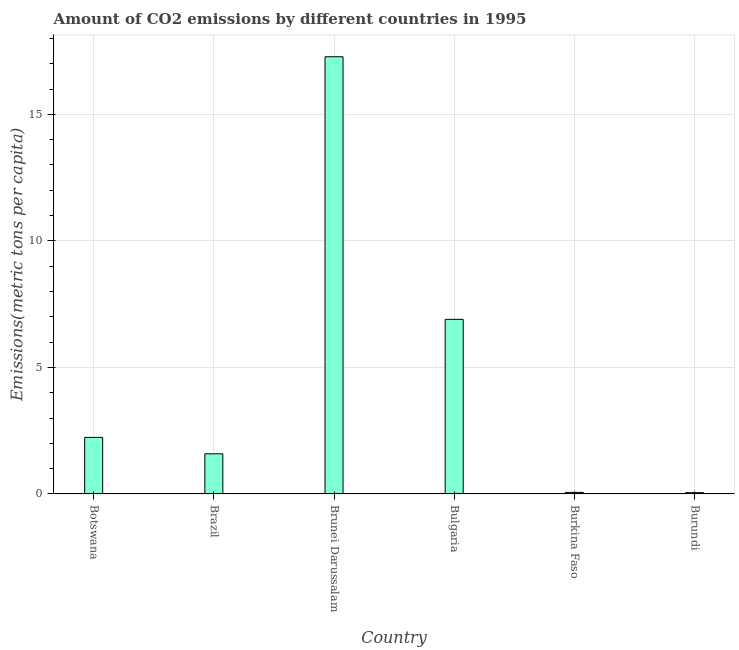Does the graph contain any zero values?
Provide a short and direct response. No. What is the title of the graph?
Offer a terse response. Amount of CO2 emissions by different countries in 1995. What is the label or title of the Y-axis?
Your answer should be compact. Emissions(metric tons per capita). What is the amount of co2 emissions in Brunei Darussalam?
Provide a short and direct response. 17.28. Across all countries, what is the maximum amount of co2 emissions?
Your response must be concise. 17.28. Across all countries, what is the minimum amount of co2 emissions?
Offer a very short reply. 0.05. In which country was the amount of co2 emissions maximum?
Give a very brief answer. Brunei Darussalam. In which country was the amount of co2 emissions minimum?
Your response must be concise. Burundi. What is the sum of the amount of co2 emissions?
Give a very brief answer. 28.11. What is the difference between the amount of co2 emissions in Brunei Darussalam and Bulgaria?
Make the answer very short. 10.38. What is the average amount of co2 emissions per country?
Offer a very short reply. 4.69. What is the median amount of co2 emissions?
Ensure brevity in your answer.  1.91. What is the ratio of the amount of co2 emissions in Brazil to that in Burundi?
Your answer should be very brief. 30.69. Is the difference between the amount of co2 emissions in Brunei Darussalam and Burkina Faso greater than the difference between any two countries?
Provide a short and direct response. No. What is the difference between the highest and the second highest amount of co2 emissions?
Keep it short and to the point. 10.38. What is the difference between the highest and the lowest amount of co2 emissions?
Offer a terse response. 17.23. In how many countries, is the amount of co2 emissions greater than the average amount of co2 emissions taken over all countries?
Your response must be concise. 2. How many bars are there?
Your answer should be compact. 6. What is the difference between two consecutive major ticks on the Y-axis?
Ensure brevity in your answer.  5. Are the values on the major ticks of Y-axis written in scientific E-notation?
Keep it short and to the point. No. What is the Emissions(metric tons per capita) in Botswana?
Your answer should be very brief. 2.24. What is the Emissions(metric tons per capita) in Brazil?
Keep it short and to the point. 1.59. What is the Emissions(metric tons per capita) of Brunei Darussalam?
Give a very brief answer. 17.28. What is the Emissions(metric tons per capita) of Bulgaria?
Your answer should be compact. 6.9. What is the Emissions(metric tons per capita) in Burkina Faso?
Keep it short and to the point. 0.06. What is the Emissions(metric tons per capita) in Burundi?
Give a very brief answer. 0.05. What is the difference between the Emissions(metric tons per capita) in Botswana and Brazil?
Your answer should be compact. 0.65. What is the difference between the Emissions(metric tons per capita) in Botswana and Brunei Darussalam?
Make the answer very short. -15.04. What is the difference between the Emissions(metric tons per capita) in Botswana and Bulgaria?
Your answer should be compact. -4.66. What is the difference between the Emissions(metric tons per capita) in Botswana and Burkina Faso?
Your answer should be very brief. 2.17. What is the difference between the Emissions(metric tons per capita) in Botswana and Burundi?
Keep it short and to the point. 2.18. What is the difference between the Emissions(metric tons per capita) in Brazil and Brunei Darussalam?
Your answer should be very brief. -15.69. What is the difference between the Emissions(metric tons per capita) in Brazil and Bulgaria?
Your answer should be compact. -5.31. What is the difference between the Emissions(metric tons per capita) in Brazil and Burkina Faso?
Ensure brevity in your answer.  1.53. What is the difference between the Emissions(metric tons per capita) in Brazil and Burundi?
Offer a terse response. 1.54. What is the difference between the Emissions(metric tons per capita) in Brunei Darussalam and Bulgaria?
Provide a short and direct response. 10.38. What is the difference between the Emissions(metric tons per capita) in Brunei Darussalam and Burkina Faso?
Provide a succinct answer. 17.22. What is the difference between the Emissions(metric tons per capita) in Brunei Darussalam and Burundi?
Your answer should be compact. 17.23. What is the difference between the Emissions(metric tons per capita) in Bulgaria and Burkina Faso?
Make the answer very short. 6.84. What is the difference between the Emissions(metric tons per capita) in Bulgaria and Burundi?
Offer a terse response. 6.85. What is the difference between the Emissions(metric tons per capita) in Burkina Faso and Burundi?
Keep it short and to the point. 0.01. What is the ratio of the Emissions(metric tons per capita) in Botswana to that in Brazil?
Provide a short and direct response. 1.41. What is the ratio of the Emissions(metric tons per capita) in Botswana to that in Brunei Darussalam?
Offer a terse response. 0.13. What is the ratio of the Emissions(metric tons per capita) in Botswana to that in Bulgaria?
Ensure brevity in your answer.  0.32. What is the ratio of the Emissions(metric tons per capita) in Botswana to that in Burkina Faso?
Provide a succinct answer. 35.97. What is the ratio of the Emissions(metric tons per capita) in Botswana to that in Burundi?
Your answer should be compact. 43.22. What is the ratio of the Emissions(metric tons per capita) in Brazil to that in Brunei Darussalam?
Your answer should be compact. 0.09. What is the ratio of the Emissions(metric tons per capita) in Brazil to that in Bulgaria?
Your response must be concise. 0.23. What is the ratio of the Emissions(metric tons per capita) in Brazil to that in Burkina Faso?
Ensure brevity in your answer.  25.54. What is the ratio of the Emissions(metric tons per capita) in Brazil to that in Burundi?
Provide a succinct answer. 30.69. What is the ratio of the Emissions(metric tons per capita) in Brunei Darussalam to that in Bulgaria?
Keep it short and to the point. 2.5. What is the ratio of the Emissions(metric tons per capita) in Brunei Darussalam to that in Burkina Faso?
Offer a terse response. 278.01. What is the ratio of the Emissions(metric tons per capita) in Brunei Darussalam to that in Burundi?
Ensure brevity in your answer.  334.05. What is the ratio of the Emissions(metric tons per capita) in Bulgaria to that in Burkina Faso?
Offer a very short reply. 111.03. What is the ratio of the Emissions(metric tons per capita) in Bulgaria to that in Burundi?
Make the answer very short. 133.41. What is the ratio of the Emissions(metric tons per capita) in Burkina Faso to that in Burundi?
Offer a terse response. 1.2. 